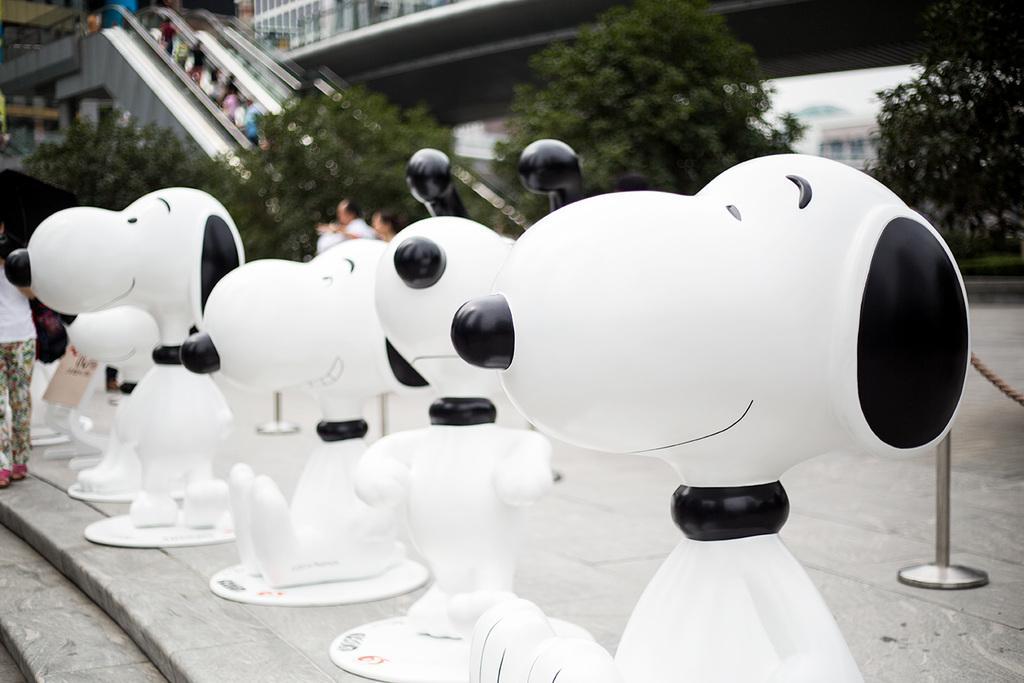Please provide a concise description of this image. This image consists of statues of dogs. At the bottom, there are steps. In the background, we can see trees and escalators. On the left, there is a person. 